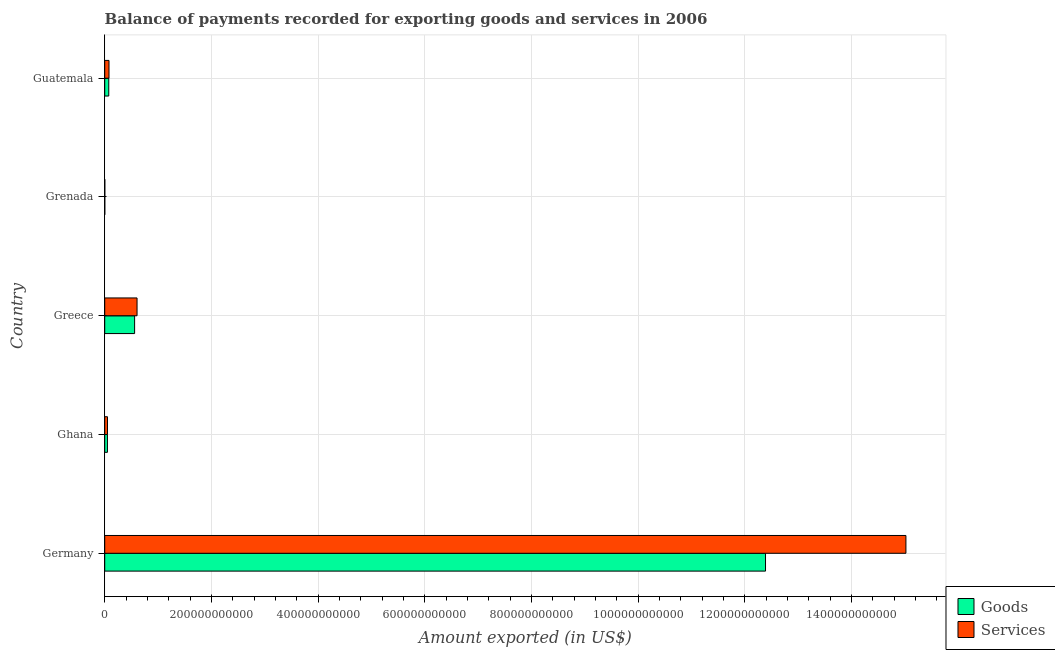How many bars are there on the 4th tick from the bottom?
Ensure brevity in your answer.  2. In how many cases, is the number of bars for a given country not equal to the number of legend labels?
Keep it short and to the point. 0. What is the amount of goods exported in Germany?
Offer a very short reply. 1.24e+12. Across all countries, what is the maximum amount of services exported?
Provide a short and direct response. 1.50e+12. Across all countries, what is the minimum amount of goods exported?
Provide a succinct answer. 1.62e+08. In which country was the amount of goods exported maximum?
Your answer should be very brief. Germany. In which country was the amount of services exported minimum?
Your answer should be compact. Grenada. What is the total amount of services exported in the graph?
Provide a succinct answer. 1.58e+12. What is the difference between the amount of goods exported in Greece and that in Guatemala?
Keep it short and to the point. 4.84e+1. What is the difference between the amount of goods exported in Guatemala and the amount of services exported in Greece?
Your answer should be very brief. -5.30e+1. What is the average amount of goods exported per country?
Offer a terse response. 2.62e+11. What is the difference between the amount of services exported and amount of goods exported in Ghana?
Provide a succinct answer. 7.33e+07. In how many countries, is the amount of goods exported greater than 320000000000 US$?
Provide a short and direct response. 1. What is the ratio of the amount of goods exported in Greece to that in Guatemala?
Your response must be concise. 7.37. Is the amount of services exported in Germany less than that in Ghana?
Ensure brevity in your answer.  No. Is the difference between the amount of services exported in Grenada and Guatemala greater than the difference between the amount of goods exported in Grenada and Guatemala?
Your answer should be very brief. No. What is the difference between the highest and the second highest amount of services exported?
Your answer should be very brief. 1.44e+12. What is the difference between the highest and the lowest amount of services exported?
Give a very brief answer. 1.50e+12. Is the sum of the amount of goods exported in Ghana and Greece greater than the maximum amount of services exported across all countries?
Keep it short and to the point. No. What does the 1st bar from the top in Grenada represents?
Your answer should be compact. Services. What does the 2nd bar from the bottom in Guatemala represents?
Make the answer very short. Services. How many bars are there?
Ensure brevity in your answer.  10. What is the difference between two consecutive major ticks on the X-axis?
Offer a very short reply. 2.00e+11. Are the values on the major ticks of X-axis written in scientific E-notation?
Provide a succinct answer. No. Where does the legend appear in the graph?
Offer a terse response. Bottom right. How many legend labels are there?
Offer a terse response. 2. How are the legend labels stacked?
Your answer should be very brief. Vertical. What is the title of the graph?
Provide a short and direct response. Balance of payments recorded for exporting goods and services in 2006. Does "Resident workers" appear as one of the legend labels in the graph?
Your response must be concise. No. What is the label or title of the X-axis?
Give a very brief answer. Amount exported (in US$). What is the label or title of the Y-axis?
Your response must be concise. Country. What is the Amount exported (in US$) in Goods in Germany?
Offer a terse response. 1.24e+12. What is the Amount exported (in US$) in Services in Germany?
Your answer should be very brief. 1.50e+12. What is the Amount exported (in US$) of Goods in Ghana?
Make the answer very short. 5.11e+09. What is the Amount exported (in US$) in Services in Ghana?
Make the answer very short. 5.18e+09. What is the Amount exported (in US$) of Goods in Greece?
Provide a short and direct response. 5.60e+1. What is the Amount exported (in US$) in Services in Greece?
Provide a short and direct response. 6.06e+1. What is the Amount exported (in US$) in Goods in Grenada?
Offer a terse response. 1.62e+08. What is the Amount exported (in US$) in Services in Grenada?
Ensure brevity in your answer.  1.76e+08. What is the Amount exported (in US$) in Goods in Guatemala?
Provide a short and direct response. 7.60e+09. What is the Amount exported (in US$) of Services in Guatemala?
Your answer should be very brief. 8.04e+09. Across all countries, what is the maximum Amount exported (in US$) of Goods?
Give a very brief answer. 1.24e+12. Across all countries, what is the maximum Amount exported (in US$) in Services?
Provide a succinct answer. 1.50e+12. Across all countries, what is the minimum Amount exported (in US$) of Goods?
Your answer should be compact. 1.62e+08. Across all countries, what is the minimum Amount exported (in US$) in Services?
Provide a succinct answer. 1.76e+08. What is the total Amount exported (in US$) of Goods in the graph?
Ensure brevity in your answer.  1.31e+12. What is the total Amount exported (in US$) in Services in the graph?
Your response must be concise. 1.58e+12. What is the difference between the Amount exported (in US$) in Goods in Germany and that in Ghana?
Offer a terse response. 1.23e+12. What is the difference between the Amount exported (in US$) in Services in Germany and that in Ghana?
Offer a very short reply. 1.50e+12. What is the difference between the Amount exported (in US$) of Goods in Germany and that in Greece?
Your answer should be compact. 1.18e+12. What is the difference between the Amount exported (in US$) of Services in Germany and that in Greece?
Your answer should be very brief. 1.44e+12. What is the difference between the Amount exported (in US$) in Goods in Germany and that in Grenada?
Your answer should be compact. 1.24e+12. What is the difference between the Amount exported (in US$) in Services in Germany and that in Grenada?
Your response must be concise. 1.50e+12. What is the difference between the Amount exported (in US$) in Goods in Germany and that in Guatemala?
Your response must be concise. 1.23e+12. What is the difference between the Amount exported (in US$) of Services in Germany and that in Guatemala?
Your response must be concise. 1.49e+12. What is the difference between the Amount exported (in US$) of Goods in Ghana and that in Greece?
Provide a succinct answer. -5.09e+1. What is the difference between the Amount exported (in US$) of Services in Ghana and that in Greece?
Offer a terse response. -5.54e+1. What is the difference between the Amount exported (in US$) in Goods in Ghana and that in Grenada?
Offer a terse response. 4.95e+09. What is the difference between the Amount exported (in US$) of Services in Ghana and that in Grenada?
Your answer should be compact. 5.01e+09. What is the difference between the Amount exported (in US$) of Goods in Ghana and that in Guatemala?
Give a very brief answer. -2.49e+09. What is the difference between the Amount exported (in US$) of Services in Ghana and that in Guatemala?
Offer a very short reply. -2.85e+09. What is the difference between the Amount exported (in US$) in Goods in Greece and that in Grenada?
Keep it short and to the point. 5.59e+1. What is the difference between the Amount exported (in US$) in Services in Greece and that in Grenada?
Your answer should be compact. 6.04e+1. What is the difference between the Amount exported (in US$) in Goods in Greece and that in Guatemala?
Provide a short and direct response. 4.84e+1. What is the difference between the Amount exported (in US$) of Services in Greece and that in Guatemala?
Make the answer very short. 5.26e+1. What is the difference between the Amount exported (in US$) in Goods in Grenada and that in Guatemala?
Ensure brevity in your answer.  -7.44e+09. What is the difference between the Amount exported (in US$) in Services in Grenada and that in Guatemala?
Make the answer very short. -7.86e+09. What is the difference between the Amount exported (in US$) of Goods in Germany and the Amount exported (in US$) of Services in Ghana?
Provide a succinct answer. 1.23e+12. What is the difference between the Amount exported (in US$) in Goods in Germany and the Amount exported (in US$) in Services in Greece?
Keep it short and to the point. 1.18e+12. What is the difference between the Amount exported (in US$) in Goods in Germany and the Amount exported (in US$) in Services in Grenada?
Make the answer very short. 1.24e+12. What is the difference between the Amount exported (in US$) of Goods in Germany and the Amount exported (in US$) of Services in Guatemala?
Your answer should be compact. 1.23e+12. What is the difference between the Amount exported (in US$) of Goods in Ghana and the Amount exported (in US$) of Services in Greece?
Your response must be concise. -5.55e+1. What is the difference between the Amount exported (in US$) in Goods in Ghana and the Amount exported (in US$) in Services in Grenada?
Make the answer very short. 4.93e+09. What is the difference between the Amount exported (in US$) in Goods in Ghana and the Amount exported (in US$) in Services in Guatemala?
Offer a terse response. -2.93e+09. What is the difference between the Amount exported (in US$) of Goods in Greece and the Amount exported (in US$) of Services in Grenada?
Offer a terse response. 5.59e+1. What is the difference between the Amount exported (in US$) of Goods in Greece and the Amount exported (in US$) of Services in Guatemala?
Your answer should be very brief. 4.80e+1. What is the difference between the Amount exported (in US$) in Goods in Grenada and the Amount exported (in US$) in Services in Guatemala?
Your answer should be very brief. -7.87e+09. What is the average Amount exported (in US$) in Goods per country?
Make the answer very short. 2.62e+11. What is the average Amount exported (in US$) in Services per country?
Offer a terse response. 3.15e+11. What is the difference between the Amount exported (in US$) in Goods and Amount exported (in US$) in Services in Germany?
Provide a short and direct response. -2.63e+11. What is the difference between the Amount exported (in US$) in Goods and Amount exported (in US$) in Services in Ghana?
Keep it short and to the point. -7.33e+07. What is the difference between the Amount exported (in US$) of Goods and Amount exported (in US$) of Services in Greece?
Give a very brief answer. -4.57e+09. What is the difference between the Amount exported (in US$) in Goods and Amount exported (in US$) in Services in Grenada?
Your answer should be compact. -1.33e+07. What is the difference between the Amount exported (in US$) in Goods and Amount exported (in US$) in Services in Guatemala?
Give a very brief answer. -4.35e+08. What is the ratio of the Amount exported (in US$) in Goods in Germany to that in Ghana?
Ensure brevity in your answer.  242.43. What is the ratio of the Amount exported (in US$) in Services in Germany to that in Ghana?
Offer a terse response. 289.79. What is the ratio of the Amount exported (in US$) in Goods in Germany to that in Greece?
Give a very brief answer. 22.11. What is the ratio of the Amount exported (in US$) of Services in Germany to that in Greece?
Provide a succinct answer. 24.78. What is the ratio of the Amount exported (in US$) of Goods in Germany to that in Grenada?
Provide a short and direct response. 7631.92. What is the ratio of the Amount exported (in US$) of Services in Germany to that in Grenada?
Make the answer very short. 8554.77. What is the ratio of the Amount exported (in US$) in Goods in Germany to that in Guatemala?
Provide a succinct answer. 162.97. What is the ratio of the Amount exported (in US$) in Services in Germany to that in Guatemala?
Offer a very short reply. 186.91. What is the ratio of the Amount exported (in US$) of Goods in Ghana to that in Greece?
Provide a short and direct response. 0.09. What is the ratio of the Amount exported (in US$) of Services in Ghana to that in Greece?
Offer a terse response. 0.09. What is the ratio of the Amount exported (in US$) in Goods in Ghana to that in Grenada?
Your response must be concise. 31.48. What is the ratio of the Amount exported (in US$) in Services in Ghana to that in Grenada?
Your answer should be very brief. 29.52. What is the ratio of the Amount exported (in US$) of Goods in Ghana to that in Guatemala?
Offer a very short reply. 0.67. What is the ratio of the Amount exported (in US$) in Services in Ghana to that in Guatemala?
Your answer should be very brief. 0.65. What is the ratio of the Amount exported (in US$) of Goods in Greece to that in Grenada?
Ensure brevity in your answer.  345.22. What is the ratio of the Amount exported (in US$) in Services in Greece to that in Grenada?
Keep it short and to the point. 345.16. What is the ratio of the Amount exported (in US$) in Goods in Greece to that in Guatemala?
Ensure brevity in your answer.  7.37. What is the ratio of the Amount exported (in US$) in Services in Greece to that in Guatemala?
Your response must be concise. 7.54. What is the ratio of the Amount exported (in US$) of Goods in Grenada to that in Guatemala?
Your response must be concise. 0.02. What is the ratio of the Amount exported (in US$) in Services in Grenada to that in Guatemala?
Offer a very short reply. 0.02. What is the difference between the highest and the second highest Amount exported (in US$) in Goods?
Your answer should be compact. 1.18e+12. What is the difference between the highest and the second highest Amount exported (in US$) of Services?
Offer a very short reply. 1.44e+12. What is the difference between the highest and the lowest Amount exported (in US$) of Goods?
Your answer should be compact. 1.24e+12. What is the difference between the highest and the lowest Amount exported (in US$) of Services?
Ensure brevity in your answer.  1.50e+12. 